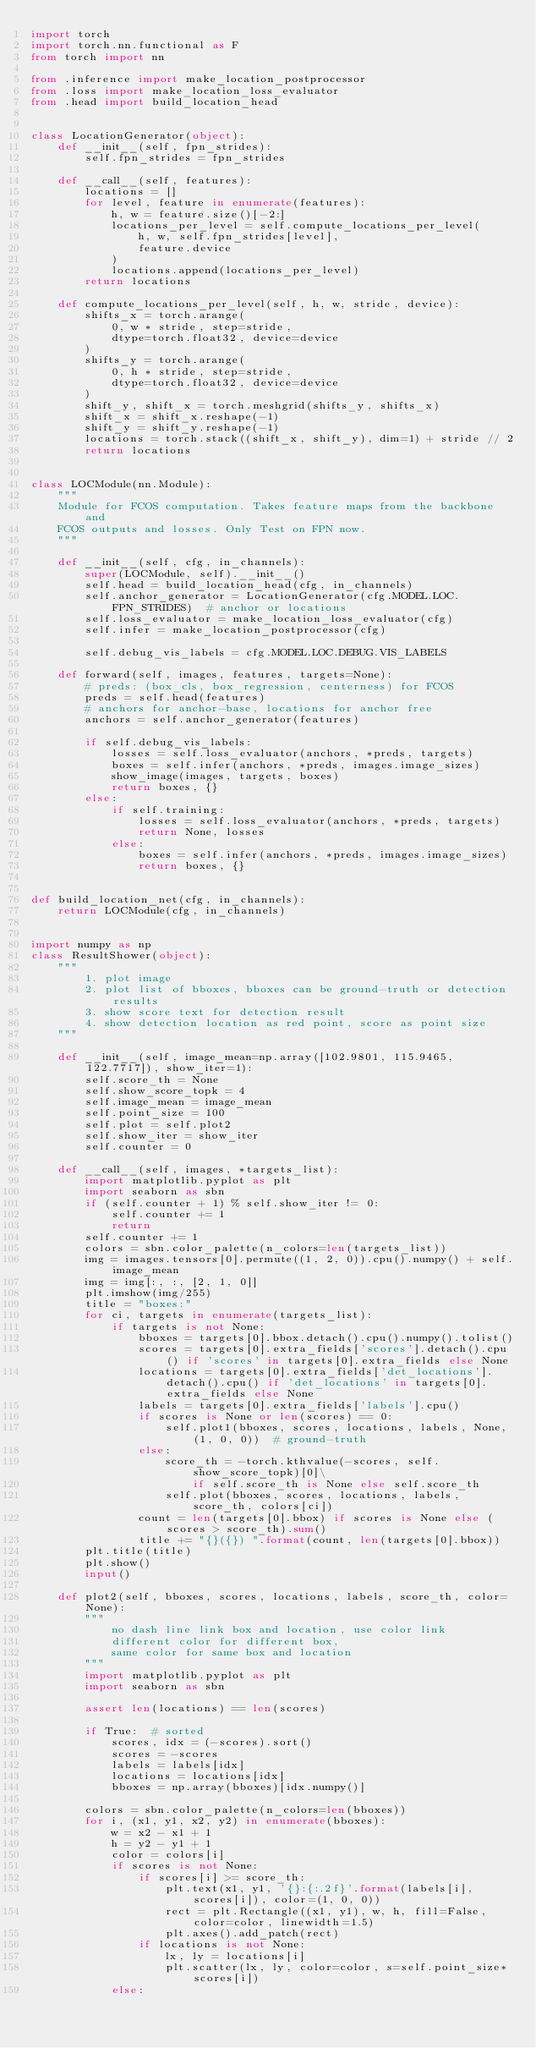<code> <loc_0><loc_0><loc_500><loc_500><_Python_>import torch
import torch.nn.functional as F
from torch import nn

from .inference import make_location_postprocessor
from .loss import make_location_loss_evaluator
from .head import build_location_head


class LocationGenerator(object):
    def __init__(self, fpn_strides):
        self.fpn_strides = fpn_strides

    def __call__(self, features):
        locations = []
        for level, feature in enumerate(features):
            h, w = feature.size()[-2:]
            locations_per_level = self.compute_locations_per_level(
                h, w, self.fpn_strides[level],
                feature.device
            )
            locations.append(locations_per_level)
        return locations

    def compute_locations_per_level(self, h, w, stride, device):
        shifts_x = torch.arange(
            0, w * stride, step=stride,
            dtype=torch.float32, device=device
        )
        shifts_y = torch.arange(
            0, h * stride, step=stride,
            dtype=torch.float32, device=device
        )
        shift_y, shift_x = torch.meshgrid(shifts_y, shifts_x)
        shift_x = shift_x.reshape(-1)
        shift_y = shift_y.reshape(-1)
        locations = torch.stack((shift_x, shift_y), dim=1) + stride // 2
        return locations


class LOCModule(nn.Module):
    """
    Module for FCOS computation. Takes feature maps from the backbone and
    FCOS outputs and losses. Only Test on FPN now.
    """

    def __init__(self, cfg, in_channels):
        super(LOCModule, self).__init__()
        self.head = build_location_head(cfg, in_channels)
        self.anchor_generator = LocationGenerator(cfg.MODEL.LOC.FPN_STRIDES)  # anchor or locations
        self.loss_evaluator = make_location_loss_evaluator(cfg)
        self.infer = make_location_postprocessor(cfg)

        self.debug_vis_labels = cfg.MODEL.LOC.DEBUG.VIS_LABELS

    def forward(self, images, features, targets=None):
        # preds: (box_cls, box_regression, centerness) for FCOS
        preds = self.head(features)
        # anchors for anchor-base, locations for anchor free
        anchors = self.anchor_generator(features)

        if self.debug_vis_labels:
            losses = self.loss_evaluator(anchors, *preds, targets)
            boxes = self.infer(anchors, *preds, images.image_sizes)
            show_image(images, targets, boxes)
            return boxes, {}
        else:
            if self.training:
                losses = self.loss_evaluator(anchors, *preds, targets)
                return None, losses
            else:
                boxes = self.infer(anchors, *preds, images.image_sizes)
                return boxes, {}


def build_location_net(cfg, in_channels):
    return LOCModule(cfg, in_channels)


import numpy as np
class ResultShower(object):
    """
        1. plot image
        2. plot list of bboxes, bboxes can be ground-truth or detection results
        3. show score text for detection result
        4. show detection location as red point, score as point size
    """

    def __init__(self, image_mean=np.array([102.9801, 115.9465, 122.7717]), show_iter=1):
        self.score_th = None
        self.show_score_topk = 4
        self.image_mean = image_mean
        self.point_size = 100
        self.plot = self.plot2
        self.show_iter = show_iter
        self.counter = 0

    def __call__(self, images, *targets_list):
        import matplotlib.pyplot as plt
        import seaborn as sbn
        if (self.counter + 1) % self.show_iter != 0:
            self.counter += 1
            return
        self.counter += 1
        colors = sbn.color_palette(n_colors=len(targets_list))
        img = images.tensors[0].permute((1, 2, 0)).cpu().numpy() + self.image_mean
        img = img[:, :, [2, 1, 0]]
        plt.imshow(img/255)
        title = "boxes:"
        for ci, targets in enumerate(targets_list):
            if targets is not None:
                bboxes = targets[0].bbox.detach().cpu().numpy().tolist()
                scores = targets[0].extra_fields['scores'].detach().cpu() if 'scores' in targets[0].extra_fields else None
                locations = targets[0].extra_fields['det_locations'].detach().cpu() if 'det_locations' in targets[0].extra_fields else None
                labels = targets[0].extra_fields['labels'].cpu()
                if scores is None or len(scores) == 0:
                    self.plot1(bboxes, scores, locations, labels, None, (1, 0, 0))  # ground-truth
                else:
                    score_th = -torch.kthvalue(-scores, self.show_score_topk)[0]\
                        if self.score_th is None else self.score_th
                    self.plot(bboxes, scores, locations, labels, score_th, colors[ci])
                count = len(targets[0].bbox) if scores is None else (scores > score_th).sum()
                title += "{}({}) ".format(count, len(targets[0].bbox))
        plt.title(title)
        plt.show()
        input()

    def plot2(self, bboxes, scores, locations, labels, score_th, color=None):
        """
            no dash line link box and location, use color link
            different color for different box,
            same color for same box and location
        """
        import matplotlib.pyplot as plt
        import seaborn as sbn

        assert len(locations) == len(scores)

        if True:  # sorted
            scores, idx = (-scores).sort()
            scores = -scores
            labels = labels[idx]
            locations = locations[idx]
            bboxes = np.array(bboxes)[idx.numpy()]

        colors = sbn.color_palette(n_colors=len(bboxes))
        for i, (x1, y1, x2, y2) in enumerate(bboxes):
            w = x2 - x1 + 1
            h = y2 - y1 + 1
            color = colors[i]
            if scores is not None:
                if scores[i] >= score_th:
                    plt.text(x1, y1, '{}:{:.2f}'.format(labels[i], scores[i]), color=(1, 0, 0))
                    rect = plt.Rectangle((x1, y1), w, h, fill=False, color=color, linewidth=1.5)
                    plt.axes().add_patch(rect)
                if locations is not None:
                    lx, ly = locations[i]
                    plt.scatter(lx, ly, color=color, s=self.point_size*scores[i])
            else:</code> 